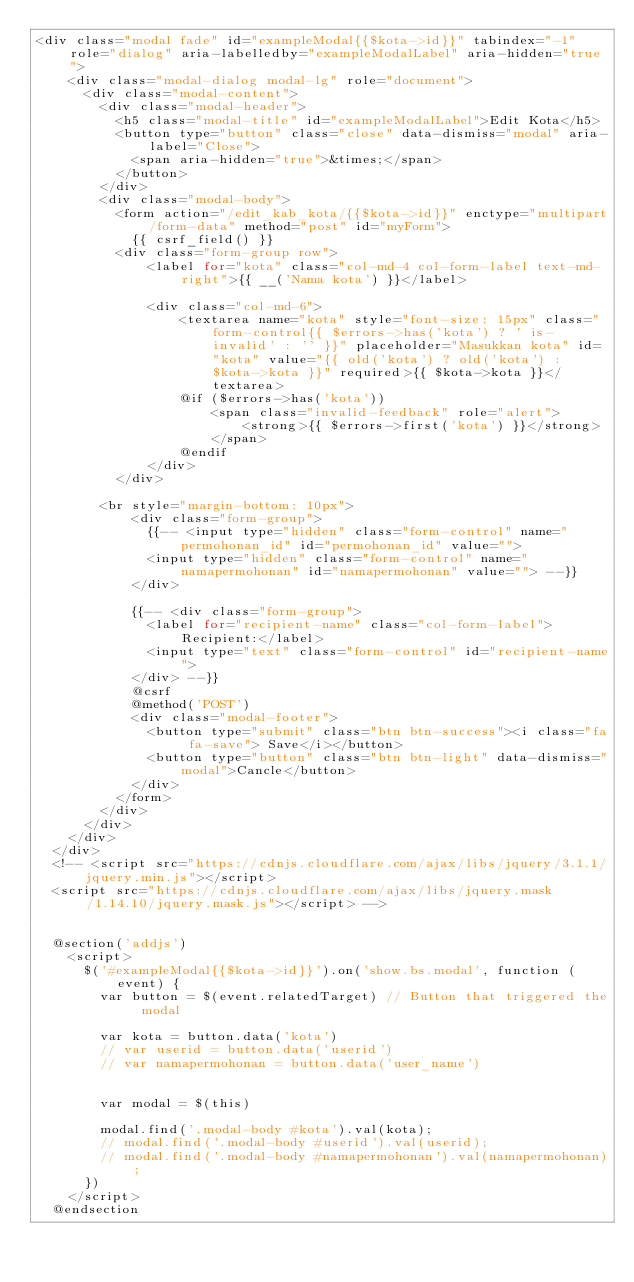<code> <loc_0><loc_0><loc_500><loc_500><_PHP_><div class="modal fade" id="exampleModal{{$kota->id}}" tabindex="-1" role="dialog" aria-labelledby="exampleModalLabel" aria-hidden="true">
    <div class="modal-dialog modal-lg" role="document">
      <div class="modal-content">
        <div class="modal-header">
          <h5 class="modal-title" id="exampleModalLabel">Edit Kota</h5>
          <button type="button" class="close" data-dismiss="modal" aria-label="Close">
            <span aria-hidden="true">&times;</span>
          </button>
        </div>
        <div class="modal-body">
          <form action="/edit_kab_kota/{{$kota->id}}" enctype="multipart/form-data" method="post" id="myForm">
            {{ csrf_field() }}
          <div class="form-group row">
              <label for="kota" class="col-md-4 col-form-label text-md-right">{{ __('Nama kota') }}</label>

              <div class="col-md-6">
                  <textarea name="kota" style="font-size: 15px" class="form-control{{ $errors->has('kota') ? ' is-invalid' : '' }}" placeholder="Masukkan kota" id="kota" value="{{ old('kota') ? old('kota') : $kota->kota }}" required>{{ $kota->kota }}</textarea>
                  @if ($errors->has('kota'))
                      <span class="invalid-feedback" role="alert">
                          <strong>{{ $errors->first('kota') }}</strong>
                      </span>
                  @endif
              </div>
          </div>

        <br style="margin-bottom: 10px">
            <div class="form-group">
              {{-- <input type="hidden" class="form-control" name="permohonan_id" id="permohonan_id" value="">
              <input type="hidden" class="form-control" name="namapermohonan" id="namapermohonan" value=""> --}}
            </div>

            {{-- <div class="form-group">
              <label for="recipient-name" class="col-form-label">Recipient:</label>
              <input type="text" class="form-control" id="recipient-name">
            </div> --}}
            @csrf
            @method('POST')
            <div class="modal-footer">
              <button type="submit" class="btn btn-success"><i class="fa fa-save"> Save</i></button>
              <button type="button" class="btn btn-light" data-dismiss="modal">Cancle</button>
            </div>
          </form>
        </div>
      </div>
    </div>
  </div>
  <!-- <script src="https://cdnjs.cloudflare.com/ajax/libs/jquery/3.1.1/jquery.min.js"></script>
  <script src="https://cdnjs.cloudflare.com/ajax/libs/jquery.mask/1.14.10/jquery.mask.js"></script> -->


  @section('addjs')
    <script>
      $('#exampleModal{{$kota->id}}').on('show.bs.modal', function (event) {
        var button = $(event.relatedTarget) // Button that triggered the modal

        var kota = button.data('kota')
        // var userid = button.data('userid')
        // var namapermohonan = button.data('user_name')


        var modal = $(this)

        modal.find('.modal-body #kota').val(kota);
        // modal.find('.modal-body #userid').val(userid);
        // modal.find('.modal-body #namapermohonan').val(namapermohonan);
      })
    </script>
  @endsection
</code> 